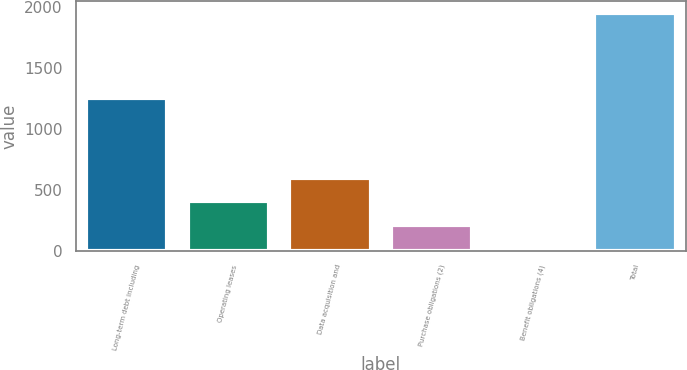Convert chart. <chart><loc_0><loc_0><loc_500><loc_500><bar_chart><fcel>Long-term debt including<fcel>Operating leases<fcel>Data acquisition and<fcel>Purchase obligations (2)<fcel>Benefit obligations (4)<fcel>Total<nl><fcel>1251<fcel>408.4<fcel>601.1<fcel>215.7<fcel>23<fcel>1950<nl></chart> 